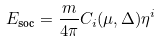Convert formula to latex. <formula><loc_0><loc_0><loc_500><loc_500>E _ { \text {soc} } = \frac { m } { 4 \pi } C _ { i } ( \mu , \Delta ) \eta ^ { i }</formula> 